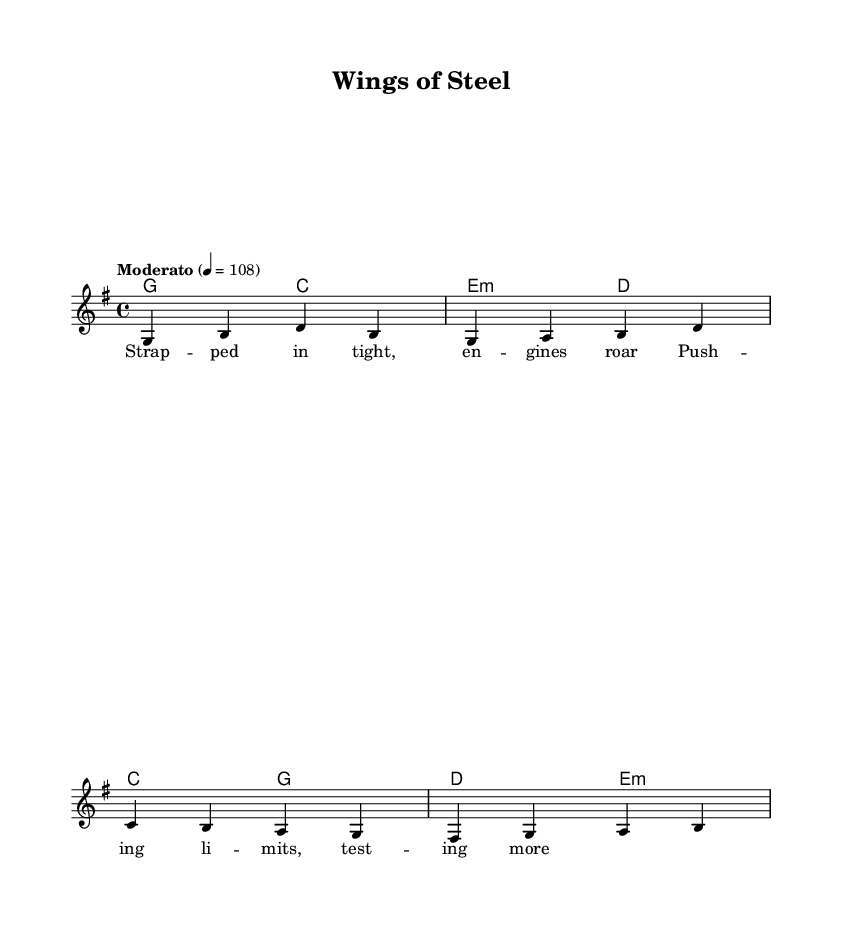What is the key signature of this music? The key signature is G major, which has one sharp (F#). The symbol for G major appears at the beginning of the staff before the notes start.
Answer: G major What is the time signature of this music? The time signature is 4/4, meaning there are four beats in each measure and the quarter note gets one beat. This can be found at the beginning of the score, near the key signature.
Answer: 4/4 What is the tempo indication for this piece? The tempo indication is "Moderato" with a metronome marking of 108 beats per minute, which is noted at the beginning of the score underneath the treble clef.
Answer: Moderato 4 = 108 What type of musical form does this piece represent? The piece represents a verse structure, as indicated by the presence of specific lyrics connected to the melody that suggests a narrative typical of country music. This is found in the lyric mode section.
Answer: Verse How many measures are in the melody section? The melody section consists of four measures, which can be counted by looking at the notation where vertical lines separate each measure.
Answer: 4 What is the quality of the chords used in the harmonies? The harmonies include major and minor chords (G, C, E minor, D), with E minor being the only minor chord, which can be inferred by recognizing the nature of the chord symbols listed in the chord mode.
Answer: Major and minor 